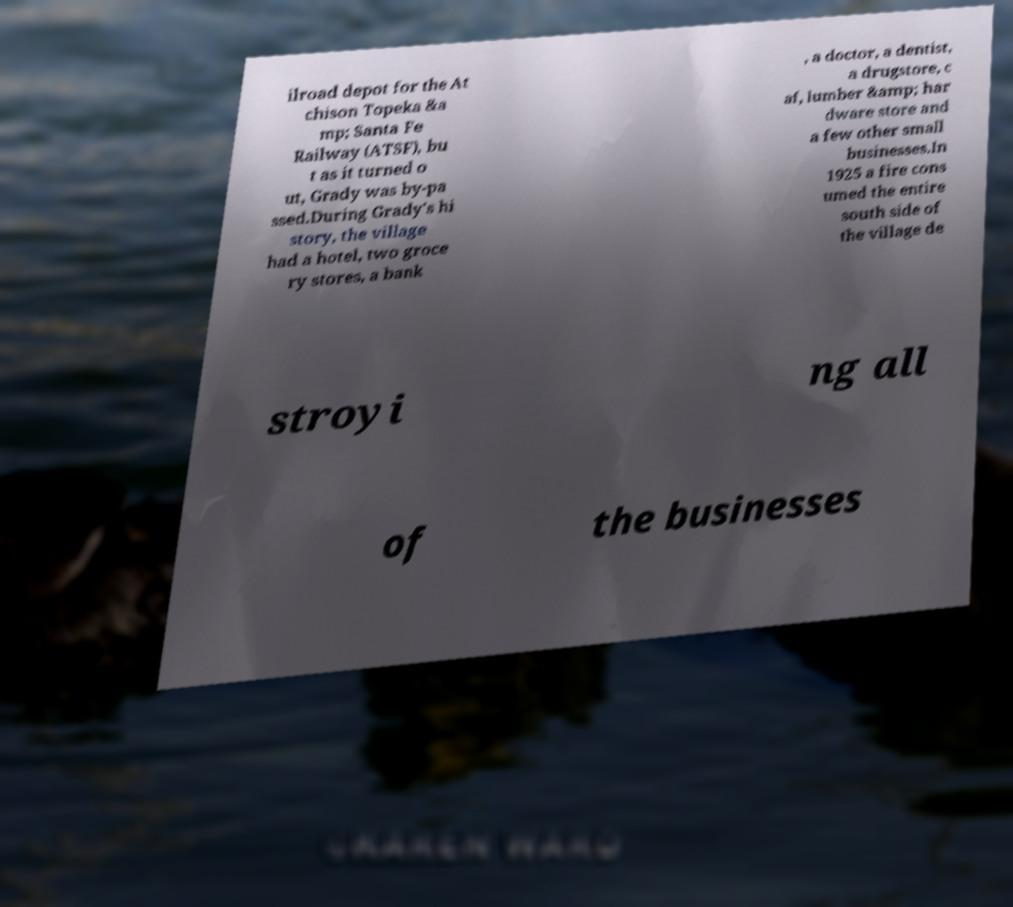What messages or text are displayed in this image? I need them in a readable, typed format. ilroad depot for the At chison Topeka &a mp; Santa Fe Railway (ATSF), bu t as it turned o ut, Grady was by-pa ssed.During Grady's hi story, the village had a hotel, two groce ry stores, a bank , a doctor, a dentist, a drugstore, c af, lumber &amp; har dware store and a few other small businesses.In 1925 a fire cons umed the entire south side of the village de stroyi ng all of the businesses 